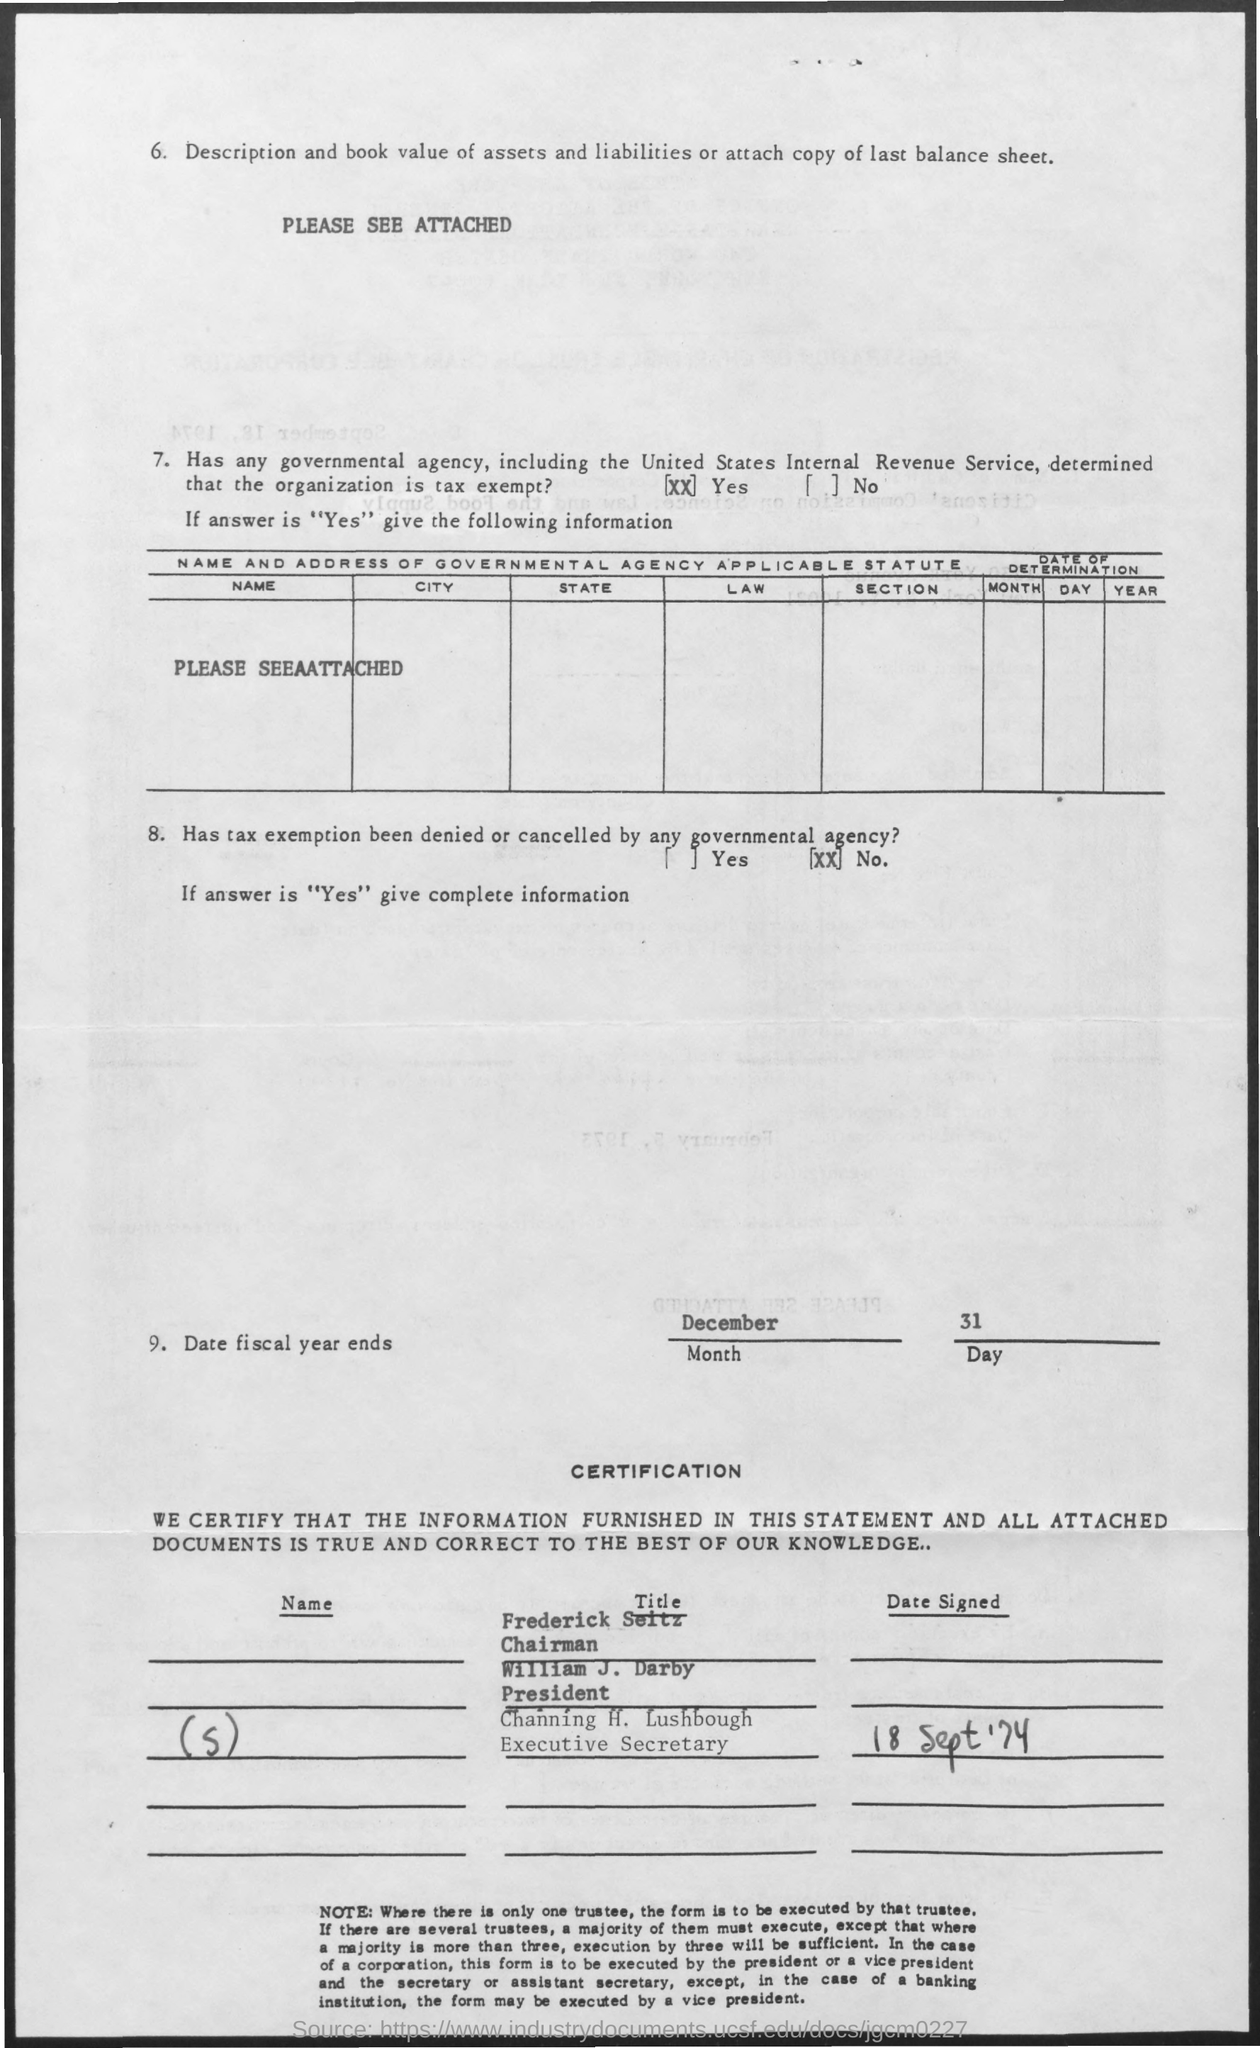Who is the Chairman?
Keep it short and to the point. Frederick Seitz. What is the designation of Channing H.Lushbough?
Provide a short and direct response. Executive Secretary. 